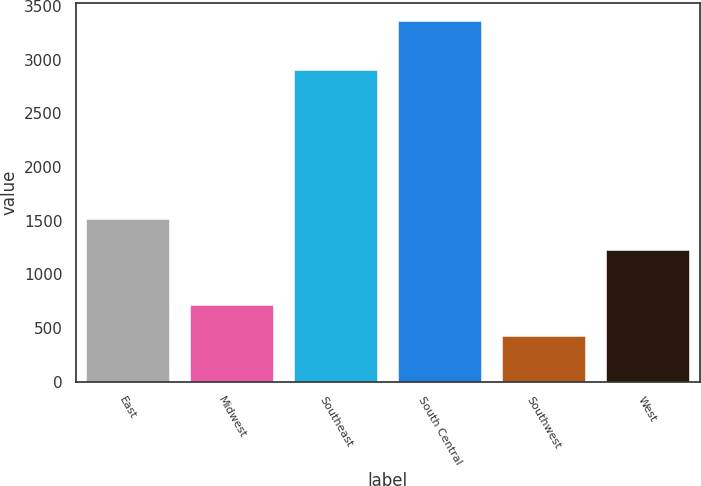Convert chart to OTSL. <chart><loc_0><loc_0><loc_500><loc_500><bar_chart><fcel>East<fcel>Midwest<fcel>Southeast<fcel>South Central<fcel>Southwest<fcel>West<nl><fcel>1519.3<fcel>718.3<fcel>2901<fcel>3358<fcel>425<fcel>1226<nl></chart> 